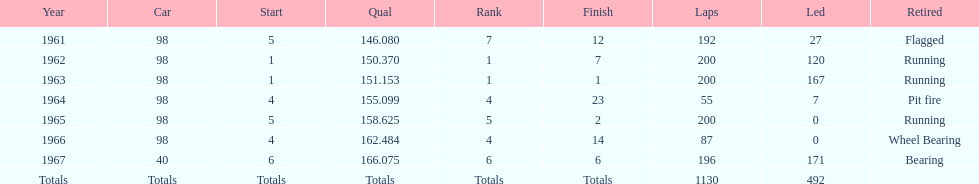When did jones secure a number 5 start at the indy 500 before 1965? 1961. 